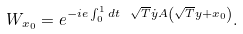Convert formula to latex. <formula><loc_0><loc_0><loc_500><loc_500>W _ { x _ { 0 } } = e ^ { - i e \int _ { 0 } ^ { 1 } d t \ \sqrt { T } \dot { y } A \left ( \sqrt { T } y + x _ { 0 } \right ) } .</formula> 